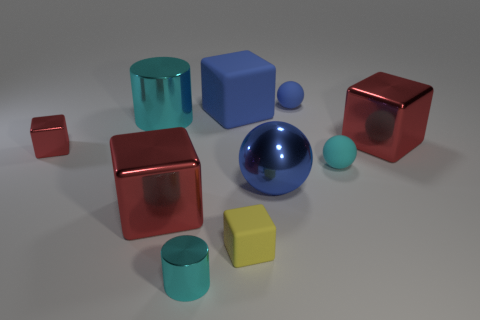Are there more metallic cylinders in front of the blue block than rubber balls in front of the yellow cube?
Offer a very short reply. Yes. What size is the other thing that is the same shape as the small cyan shiny thing?
Keep it short and to the point. Large. How many blocks are tiny rubber things or big objects?
Ensure brevity in your answer.  4. What material is the big thing that is the same color as the large sphere?
Offer a terse response. Rubber. Is the number of big metallic things that are in front of the yellow block less than the number of red metal objects on the right side of the tiny metal cube?
Provide a succinct answer. Yes. What number of objects are objects that are left of the big sphere or blue objects?
Keep it short and to the point. 8. The red shiny object that is right of the tiny cyan thing to the left of the large blue block is what shape?
Give a very brief answer. Cube. Are there any cyan metal cylinders that have the same size as the yellow matte object?
Make the answer very short. Yes. Is the number of tiny cyan things greater than the number of large cubes?
Offer a very short reply. No. There is a red thing that is right of the small cyan sphere; is it the same size as the cyan shiny object behind the tiny rubber block?
Your answer should be compact. Yes. 